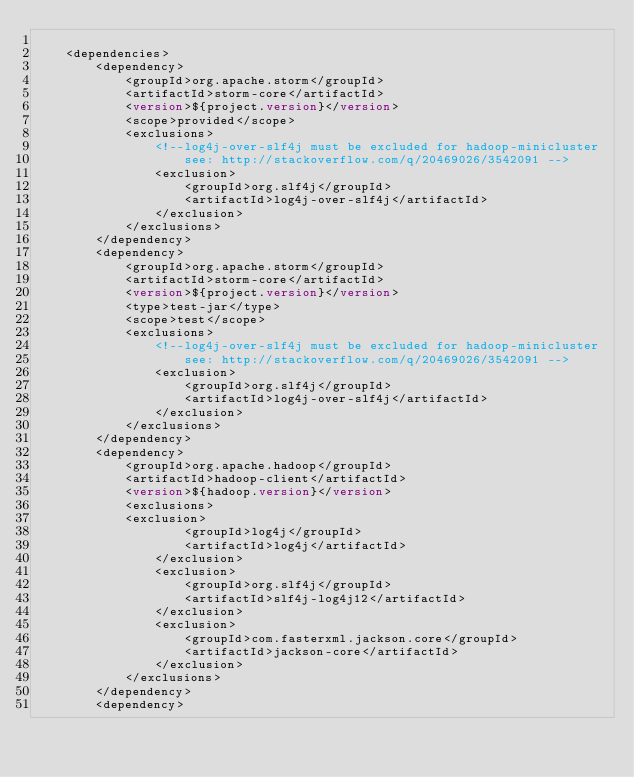Convert code to text. <code><loc_0><loc_0><loc_500><loc_500><_XML_>
    <dependencies>
        <dependency>
            <groupId>org.apache.storm</groupId>
            <artifactId>storm-core</artifactId>
            <version>${project.version}</version>
            <scope>provided</scope>
            <exclusions>
                <!--log4j-over-slf4j must be excluded for hadoop-minicluster
                    see: http://stackoverflow.com/q/20469026/3542091 -->
                <exclusion>
                    <groupId>org.slf4j</groupId>
                    <artifactId>log4j-over-slf4j</artifactId>
                </exclusion>
            </exclusions>
        </dependency>
        <dependency>
            <groupId>org.apache.storm</groupId>
            <artifactId>storm-core</artifactId>
            <version>${project.version}</version>
            <type>test-jar</type>
            <scope>test</scope>
            <exclusions>
                <!--log4j-over-slf4j must be excluded for hadoop-minicluster
                    see: http://stackoverflow.com/q/20469026/3542091 -->
                <exclusion>
                    <groupId>org.slf4j</groupId>
                    <artifactId>log4j-over-slf4j</artifactId>
                </exclusion>
            </exclusions>
        </dependency>
        <dependency>
            <groupId>org.apache.hadoop</groupId>
            <artifactId>hadoop-client</artifactId>
            <version>${hadoop.version}</version>
            <exclusions>
	    	<exclusion>
                    <groupId>log4j</groupId>
                    <artifactId>log4j</artifactId>
                </exclusion>
                <exclusion>
                    <groupId>org.slf4j</groupId>
                    <artifactId>slf4j-log4j12</artifactId>
                </exclusion>
                <exclusion>
                    <groupId>com.fasterxml.jackson.core</groupId>
                    <artifactId>jackson-core</artifactId>
                </exclusion>
            </exclusions>
        </dependency>
        <dependency></code> 